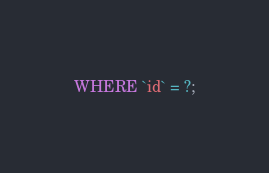<code> <loc_0><loc_0><loc_500><loc_500><_SQL_>WHERE `id` = ?;</code> 